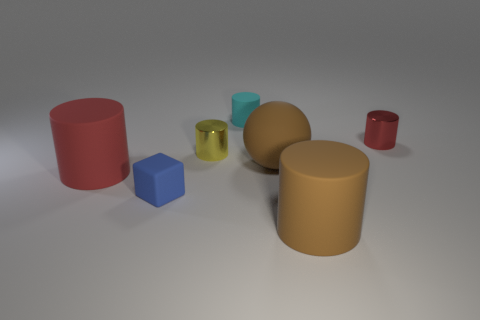Subtract all large red rubber cylinders. How many cylinders are left? 4 Subtract all brown cylinders. How many cylinders are left? 4 Subtract 1 cylinders. How many cylinders are left? 4 Subtract all blue cylinders. Subtract all purple spheres. How many cylinders are left? 5 Add 1 tiny metallic objects. How many objects exist? 8 Subtract all cubes. How many objects are left? 6 Subtract all tiny cyan rubber balls. Subtract all small yellow cylinders. How many objects are left? 6 Add 7 blue matte things. How many blue matte things are left? 8 Add 1 blue cubes. How many blue cubes exist? 2 Subtract 0 red cubes. How many objects are left? 7 